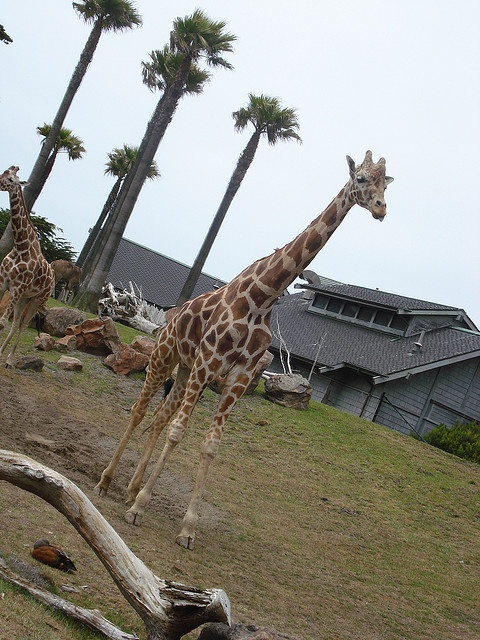Describe the objects in this image and their specific colors. I can see giraffe in white, gray, and maroon tones and giraffe in white, gray, black, and maroon tones in this image. 